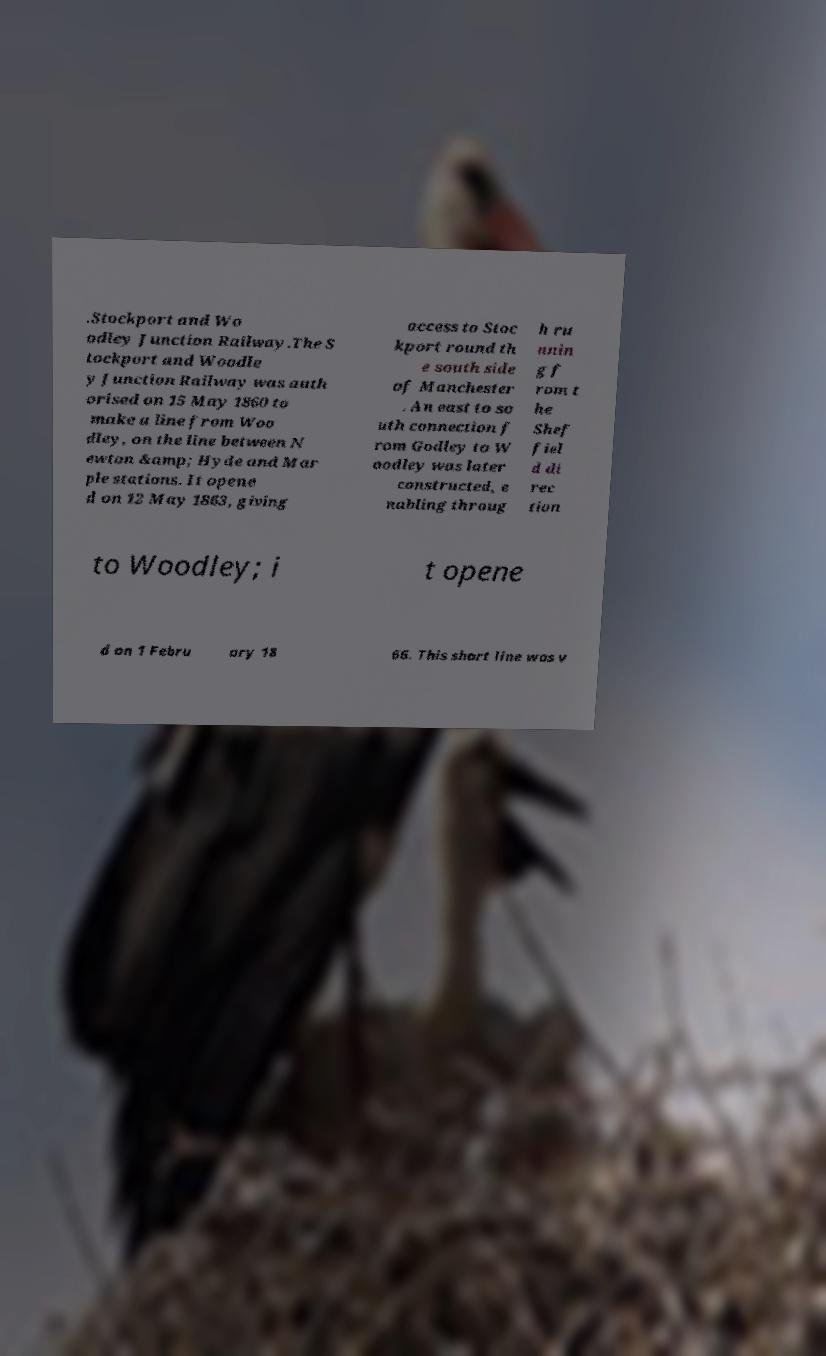I need the written content from this picture converted into text. Can you do that? .Stockport and Wo odley Junction Railway.The S tockport and Woodle y Junction Railway was auth orised on 15 May 1860 to make a line from Woo dley, on the line between N ewton &amp; Hyde and Mar ple stations. It opene d on 12 May 1863, giving access to Stoc kport round th e south side of Manchester . An east to so uth connection f rom Godley to W oodley was later constructed, e nabling throug h ru nnin g f rom t he Shef fiel d di rec tion to Woodley; i t opene d on 1 Febru ary 18 66. This short line was v 